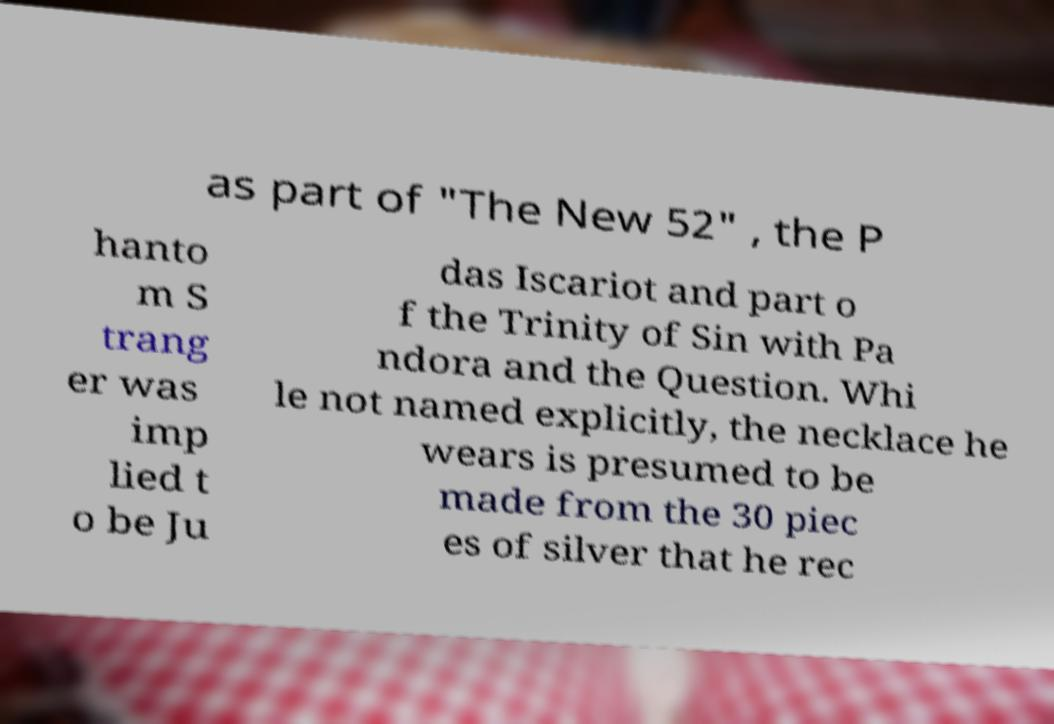What messages or text are displayed in this image? I need them in a readable, typed format. as part of "The New 52" , the P hanto m S trang er was imp lied t o be Ju das Iscariot and part o f the Trinity of Sin with Pa ndora and the Question. Whi le not named explicitly, the necklace he wears is presumed to be made from the 30 piec es of silver that he rec 